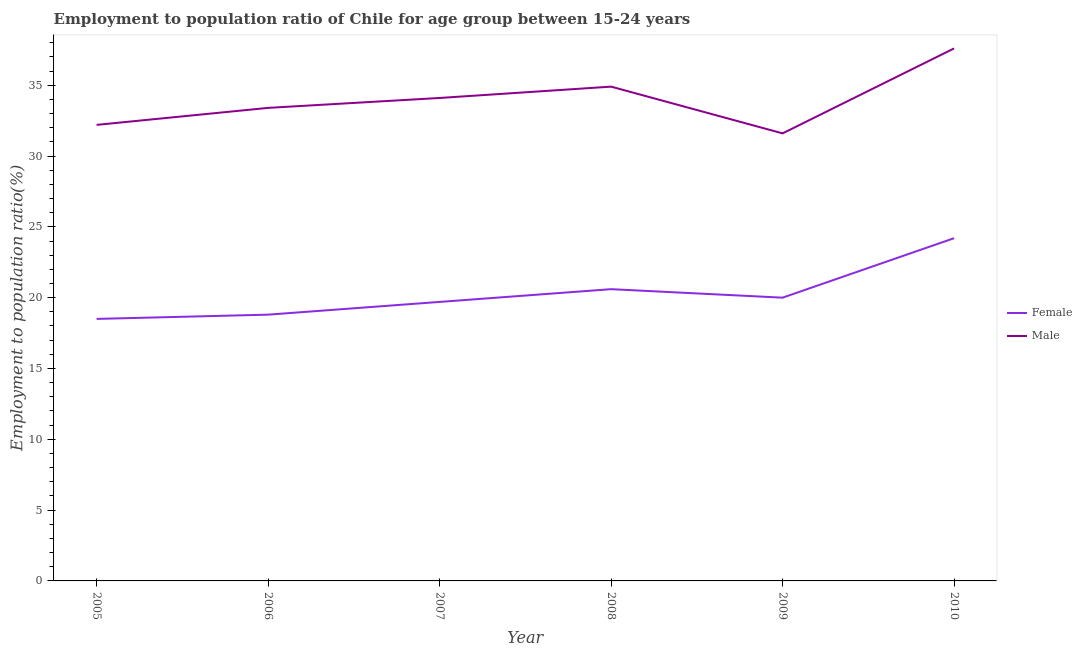How many different coloured lines are there?
Your answer should be compact. 2. Is the number of lines equal to the number of legend labels?
Keep it short and to the point. Yes. What is the employment to population ratio(female) in 2007?
Offer a terse response. 19.7. Across all years, what is the maximum employment to population ratio(male)?
Offer a terse response. 37.6. Across all years, what is the minimum employment to population ratio(male)?
Offer a very short reply. 31.6. In which year was the employment to population ratio(male) maximum?
Give a very brief answer. 2010. In which year was the employment to population ratio(female) minimum?
Keep it short and to the point. 2005. What is the total employment to population ratio(female) in the graph?
Keep it short and to the point. 121.8. What is the difference between the employment to population ratio(female) in 2008 and that in 2009?
Your response must be concise. 0.6. What is the difference between the employment to population ratio(female) in 2006 and the employment to population ratio(male) in 2007?
Provide a succinct answer. -15.3. What is the average employment to population ratio(female) per year?
Make the answer very short. 20.3. In the year 2008, what is the difference between the employment to population ratio(female) and employment to population ratio(male)?
Provide a short and direct response. -14.3. What is the ratio of the employment to population ratio(female) in 2007 to that in 2009?
Provide a short and direct response. 0.99. Is the difference between the employment to population ratio(female) in 2008 and 2010 greater than the difference between the employment to population ratio(male) in 2008 and 2010?
Offer a very short reply. No. What is the difference between the highest and the second highest employment to population ratio(male)?
Offer a very short reply. 2.7. What is the difference between the highest and the lowest employment to population ratio(female)?
Give a very brief answer. 5.7. Is the sum of the employment to population ratio(female) in 2008 and 2009 greater than the maximum employment to population ratio(male) across all years?
Keep it short and to the point. Yes. Does the employment to population ratio(male) monotonically increase over the years?
Your answer should be very brief. No. Is the employment to population ratio(female) strictly greater than the employment to population ratio(male) over the years?
Your answer should be very brief. No. How many lines are there?
Provide a short and direct response. 2. Are the values on the major ticks of Y-axis written in scientific E-notation?
Provide a succinct answer. No. Where does the legend appear in the graph?
Your response must be concise. Center right. How many legend labels are there?
Offer a terse response. 2. What is the title of the graph?
Keep it short and to the point. Employment to population ratio of Chile for age group between 15-24 years. What is the label or title of the Y-axis?
Offer a very short reply. Employment to population ratio(%). What is the Employment to population ratio(%) in Female in 2005?
Provide a succinct answer. 18.5. What is the Employment to population ratio(%) of Male in 2005?
Your answer should be very brief. 32.2. What is the Employment to population ratio(%) of Female in 2006?
Ensure brevity in your answer.  18.8. What is the Employment to population ratio(%) in Male in 2006?
Provide a short and direct response. 33.4. What is the Employment to population ratio(%) of Female in 2007?
Make the answer very short. 19.7. What is the Employment to population ratio(%) in Male in 2007?
Provide a succinct answer. 34.1. What is the Employment to population ratio(%) of Female in 2008?
Ensure brevity in your answer.  20.6. What is the Employment to population ratio(%) in Male in 2008?
Offer a very short reply. 34.9. What is the Employment to population ratio(%) of Male in 2009?
Offer a very short reply. 31.6. What is the Employment to population ratio(%) in Female in 2010?
Keep it short and to the point. 24.2. What is the Employment to population ratio(%) in Male in 2010?
Give a very brief answer. 37.6. Across all years, what is the maximum Employment to population ratio(%) in Female?
Offer a terse response. 24.2. Across all years, what is the maximum Employment to population ratio(%) of Male?
Provide a short and direct response. 37.6. Across all years, what is the minimum Employment to population ratio(%) of Female?
Your answer should be very brief. 18.5. Across all years, what is the minimum Employment to population ratio(%) in Male?
Ensure brevity in your answer.  31.6. What is the total Employment to population ratio(%) of Female in the graph?
Your response must be concise. 121.8. What is the total Employment to population ratio(%) in Male in the graph?
Provide a succinct answer. 203.8. What is the difference between the Employment to population ratio(%) in Female in 2005 and that in 2006?
Your answer should be compact. -0.3. What is the difference between the Employment to population ratio(%) of Male in 2005 and that in 2006?
Offer a very short reply. -1.2. What is the difference between the Employment to population ratio(%) of Male in 2005 and that in 2007?
Your answer should be compact. -1.9. What is the difference between the Employment to population ratio(%) of Male in 2005 and that in 2008?
Make the answer very short. -2.7. What is the difference between the Employment to population ratio(%) of Female in 2005 and that in 2009?
Keep it short and to the point. -1.5. What is the difference between the Employment to population ratio(%) in Female in 2006 and that in 2007?
Provide a succinct answer. -0.9. What is the difference between the Employment to population ratio(%) in Male in 2006 and that in 2007?
Give a very brief answer. -0.7. What is the difference between the Employment to population ratio(%) of Female in 2006 and that in 2008?
Give a very brief answer. -1.8. What is the difference between the Employment to population ratio(%) in Male in 2006 and that in 2008?
Give a very brief answer. -1.5. What is the difference between the Employment to population ratio(%) of Female in 2006 and that in 2009?
Keep it short and to the point. -1.2. What is the difference between the Employment to population ratio(%) of Male in 2006 and that in 2009?
Your answer should be compact. 1.8. What is the difference between the Employment to population ratio(%) of Male in 2006 and that in 2010?
Your answer should be very brief. -4.2. What is the difference between the Employment to population ratio(%) of Female in 2007 and that in 2010?
Your answer should be compact. -4.5. What is the difference between the Employment to population ratio(%) in Male in 2007 and that in 2010?
Offer a very short reply. -3.5. What is the difference between the Employment to population ratio(%) of Male in 2008 and that in 2009?
Keep it short and to the point. 3.3. What is the difference between the Employment to population ratio(%) of Male in 2009 and that in 2010?
Your answer should be very brief. -6. What is the difference between the Employment to population ratio(%) in Female in 2005 and the Employment to population ratio(%) in Male in 2006?
Offer a terse response. -14.9. What is the difference between the Employment to population ratio(%) of Female in 2005 and the Employment to population ratio(%) of Male in 2007?
Provide a succinct answer. -15.6. What is the difference between the Employment to population ratio(%) of Female in 2005 and the Employment to population ratio(%) of Male in 2008?
Your response must be concise. -16.4. What is the difference between the Employment to population ratio(%) in Female in 2005 and the Employment to population ratio(%) in Male in 2009?
Your answer should be very brief. -13.1. What is the difference between the Employment to population ratio(%) of Female in 2005 and the Employment to population ratio(%) of Male in 2010?
Offer a very short reply. -19.1. What is the difference between the Employment to population ratio(%) in Female in 2006 and the Employment to population ratio(%) in Male in 2007?
Keep it short and to the point. -15.3. What is the difference between the Employment to population ratio(%) in Female in 2006 and the Employment to population ratio(%) in Male in 2008?
Give a very brief answer. -16.1. What is the difference between the Employment to population ratio(%) in Female in 2006 and the Employment to population ratio(%) in Male in 2010?
Give a very brief answer. -18.8. What is the difference between the Employment to population ratio(%) of Female in 2007 and the Employment to population ratio(%) of Male in 2008?
Your response must be concise. -15.2. What is the difference between the Employment to population ratio(%) of Female in 2007 and the Employment to population ratio(%) of Male in 2010?
Make the answer very short. -17.9. What is the difference between the Employment to population ratio(%) in Female in 2008 and the Employment to population ratio(%) in Male in 2009?
Your response must be concise. -11. What is the difference between the Employment to population ratio(%) in Female in 2009 and the Employment to population ratio(%) in Male in 2010?
Your answer should be very brief. -17.6. What is the average Employment to population ratio(%) of Female per year?
Your response must be concise. 20.3. What is the average Employment to population ratio(%) of Male per year?
Provide a succinct answer. 33.97. In the year 2005, what is the difference between the Employment to population ratio(%) of Female and Employment to population ratio(%) of Male?
Provide a short and direct response. -13.7. In the year 2006, what is the difference between the Employment to population ratio(%) in Female and Employment to population ratio(%) in Male?
Offer a terse response. -14.6. In the year 2007, what is the difference between the Employment to population ratio(%) in Female and Employment to population ratio(%) in Male?
Ensure brevity in your answer.  -14.4. In the year 2008, what is the difference between the Employment to population ratio(%) of Female and Employment to population ratio(%) of Male?
Ensure brevity in your answer.  -14.3. In the year 2009, what is the difference between the Employment to population ratio(%) in Female and Employment to population ratio(%) in Male?
Provide a succinct answer. -11.6. In the year 2010, what is the difference between the Employment to population ratio(%) in Female and Employment to population ratio(%) in Male?
Keep it short and to the point. -13.4. What is the ratio of the Employment to population ratio(%) in Male in 2005 to that in 2006?
Ensure brevity in your answer.  0.96. What is the ratio of the Employment to population ratio(%) of Female in 2005 to that in 2007?
Make the answer very short. 0.94. What is the ratio of the Employment to population ratio(%) in Male in 2005 to that in 2007?
Offer a very short reply. 0.94. What is the ratio of the Employment to population ratio(%) in Female in 2005 to that in 2008?
Provide a succinct answer. 0.9. What is the ratio of the Employment to population ratio(%) of Male in 2005 to that in 2008?
Offer a very short reply. 0.92. What is the ratio of the Employment to population ratio(%) in Female in 2005 to that in 2009?
Provide a short and direct response. 0.93. What is the ratio of the Employment to population ratio(%) of Female in 2005 to that in 2010?
Give a very brief answer. 0.76. What is the ratio of the Employment to population ratio(%) of Male in 2005 to that in 2010?
Your response must be concise. 0.86. What is the ratio of the Employment to population ratio(%) in Female in 2006 to that in 2007?
Make the answer very short. 0.95. What is the ratio of the Employment to population ratio(%) of Male in 2006 to that in 2007?
Your response must be concise. 0.98. What is the ratio of the Employment to population ratio(%) of Female in 2006 to that in 2008?
Give a very brief answer. 0.91. What is the ratio of the Employment to population ratio(%) of Male in 2006 to that in 2008?
Provide a succinct answer. 0.96. What is the ratio of the Employment to population ratio(%) of Female in 2006 to that in 2009?
Make the answer very short. 0.94. What is the ratio of the Employment to population ratio(%) in Male in 2006 to that in 2009?
Your answer should be compact. 1.06. What is the ratio of the Employment to population ratio(%) in Female in 2006 to that in 2010?
Keep it short and to the point. 0.78. What is the ratio of the Employment to population ratio(%) in Male in 2006 to that in 2010?
Your answer should be very brief. 0.89. What is the ratio of the Employment to population ratio(%) of Female in 2007 to that in 2008?
Offer a terse response. 0.96. What is the ratio of the Employment to population ratio(%) of Male in 2007 to that in 2008?
Make the answer very short. 0.98. What is the ratio of the Employment to population ratio(%) in Female in 2007 to that in 2009?
Keep it short and to the point. 0.98. What is the ratio of the Employment to population ratio(%) of Male in 2007 to that in 2009?
Give a very brief answer. 1.08. What is the ratio of the Employment to population ratio(%) of Female in 2007 to that in 2010?
Offer a very short reply. 0.81. What is the ratio of the Employment to population ratio(%) of Male in 2007 to that in 2010?
Your answer should be compact. 0.91. What is the ratio of the Employment to population ratio(%) in Female in 2008 to that in 2009?
Your answer should be very brief. 1.03. What is the ratio of the Employment to population ratio(%) of Male in 2008 to that in 2009?
Offer a terse response. 1.1. What is the ratio of the Employment to population ratio(%) of Female in 2008 to that in 2010?
Provide a short and direct response. 0.85. What is the ratio of the Employment to population ratio(%) of Male in 2008 to that in 2010?
Your answer should be compact. 0.93. What is the ratio of the Employment to population ratio(%) of Female in 2009 to that in 2010?
Offer a very short reply. 0.83. What is the ratio of the Employment to population ratio(%) in Male in 2009 to that in 2010?
Your answer should be very brief. 0.84. What is the difference between the highest and the lowest Employment to population ratio(%) of Female?
Provide a succinct answer. 5.7. What is the difference between the highest and the lowest Employment to population ratio(%) in Male?
Offer a very short reply. 6. 